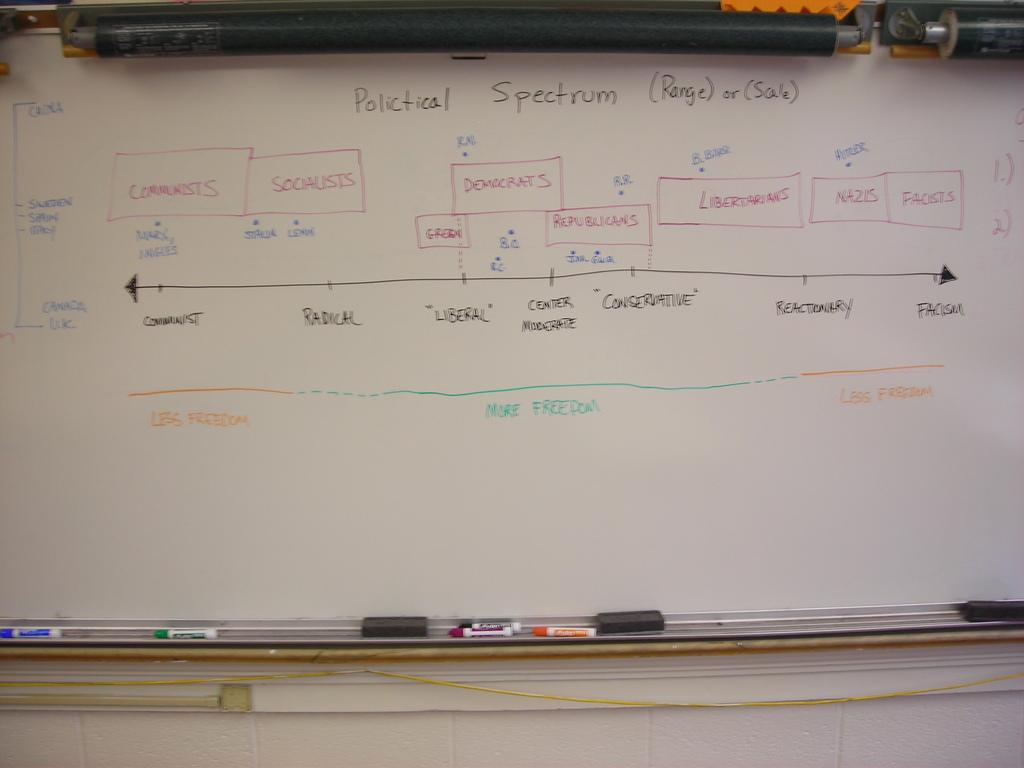<image>
Provide a brief description of the given image. A whiteboard that illustrates the entrie political spectrum. 